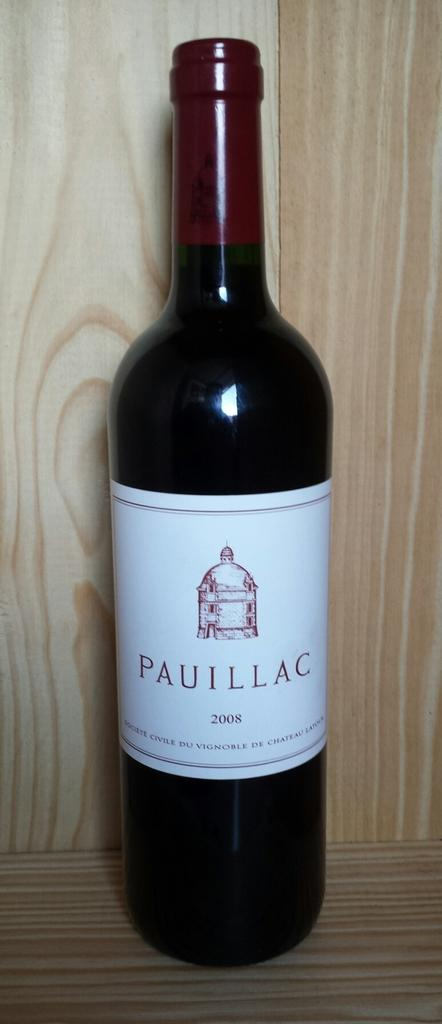<image>
Write a terse but informative summary of the picture. A bottle of Pauillac from 2008 sits on a wooden shelf. 